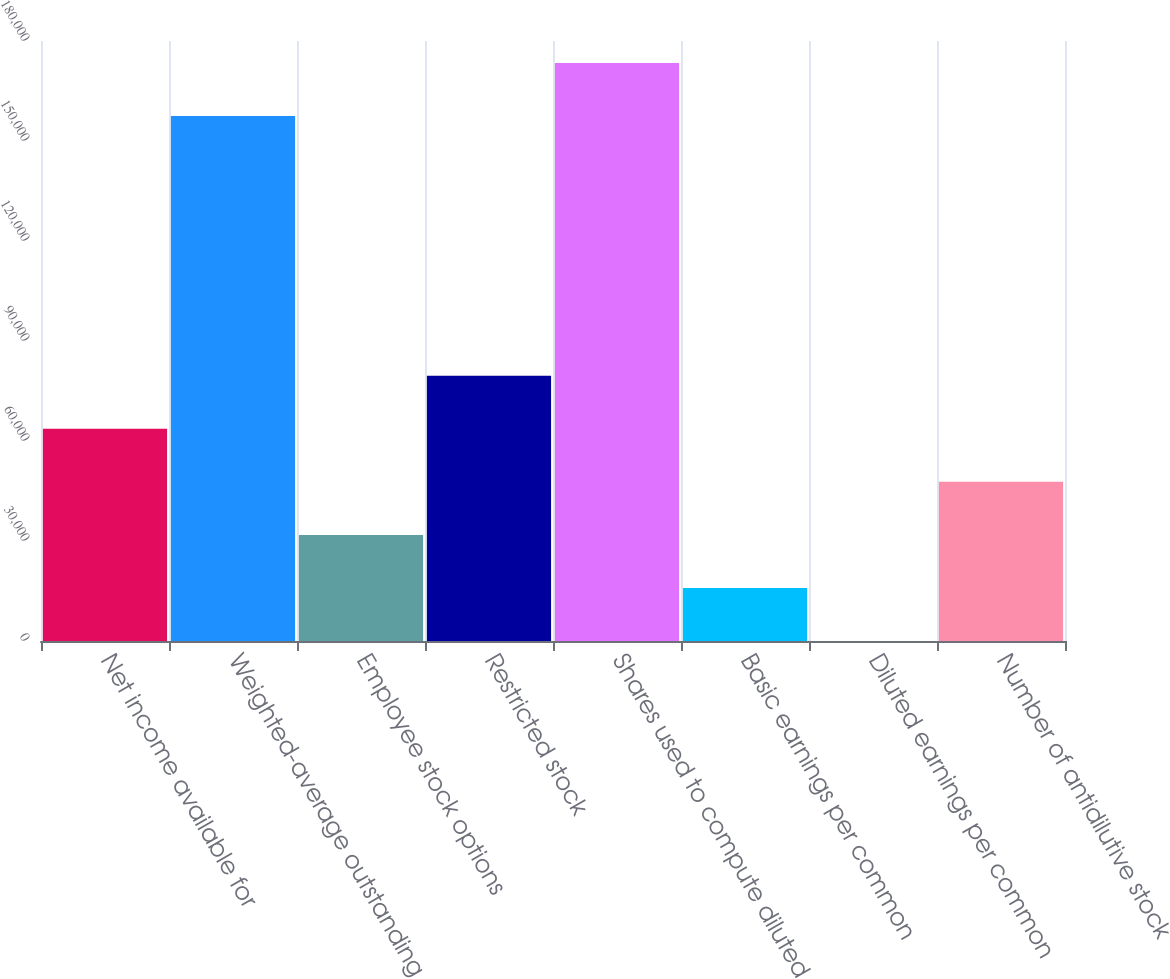Convert chart to OTSL. <chart><loc_0><loc_0><loc_500><loc_500><bar_chart><fcel>Net income available for<fcel>Weighted-average outstanding<fcel>Employee stock options<fcel>Restricted stock<fcel>Shares used to compute diluted<fcel>Basic earnings per common<fcel>Diluted earnings per common<fcel>Number of antidilutive stock<nl><fcel>63665.1<fcel>157503<fcel>31836.4<fcel>79579.4<fcel>173417<fcel>15922.1<fcel>7.73<fcel>47750.7<nl></chart> 